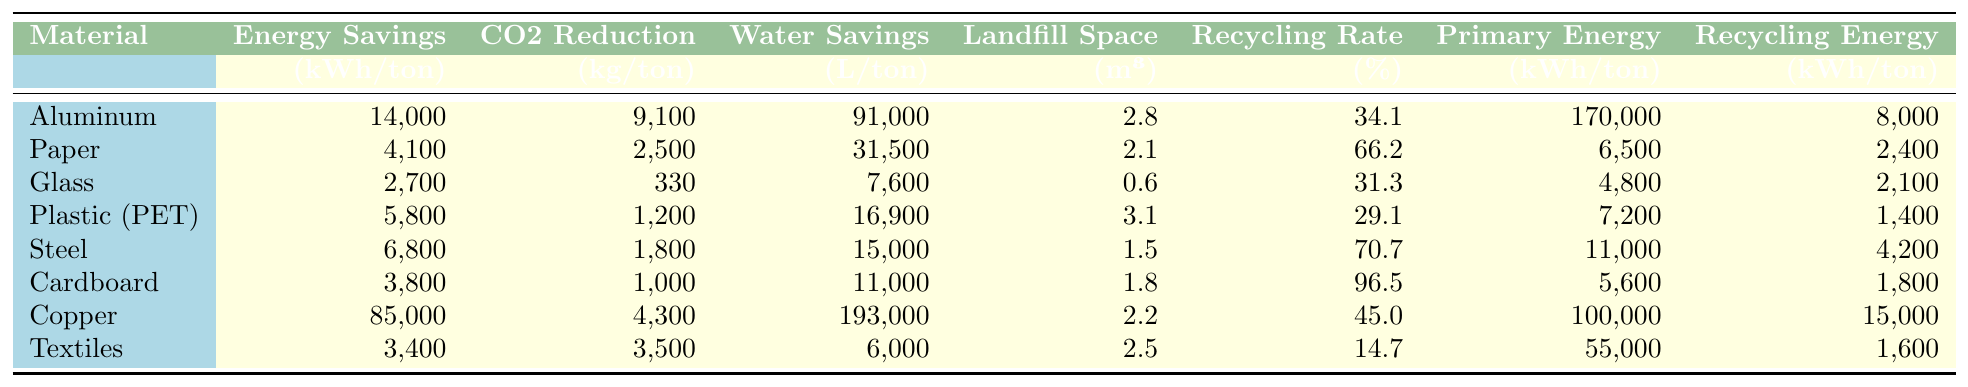What material has the highest CO2 emissions reduction per ton? By examining the "CO2 Reduction" column, we can see that Copper has the highest value of 4,300 kg per ton compared to other materials listed.
Answer: Copper What is the energy savings per ton for Cardboard? Looking under the "Energy Savings" column for Cardboard, the value is 3,800 kWh per ton.
Answer: 3,800 kWh Which material has the lowest recycling rate? Among the recycling rates listed, Textiles has the lowest rate at 14.7%.
Answer: Textiles What is the difference in CO2 emissions reduction between Aluminum and Plastic (PET)? The CO2 emissions reduction for Aluminum is 9,100 kg and for Plastic (PET) it is 1,200 kg. Therefore, the difference is 9,100 - 1,200 = 7,900 kg.
Answer: 7,900 kg What is the average energy savings for all materials listed? The total energy savings is the sum of all values in the "Energy Savings" column, which equals 14,000 + 4,100 + 2,700 + 5,800 + 6,800 + 3,800 + 85,000 + 3,400 = 125,700 kWh. Dividing this by 8 (the number of materials), the average is 125,700 / 8 = 15,712.5 kWh per ton.
Answer: 15,712.5 kWh Is the water savings per ton higher for Steel than for Glass? The water savings for Steel is 15,000 liters, while for Glass it is 7,600 liters. Since 15,000 is greater than 7,600, the statement is true.
Answer: Yes What material saves the most water per ton? By checking the "Water Savings" column, we find that Copper has the highest value of 193,000 liters per ton, which is greater than all other materials.
Answer: Copper Which material has the second highest energy savings after Copper? The next highest energy savings after Copper (85,000 kWh) is Aluminum at 14,000 kWh.
Answer: Aluminum If we combine the CO2 reduction of Cardboard and Glass, what is the total reduction? Cardboard has a CO2 reduction of 1,000 kg, and Glass has 330 kg. Adding these two values together, we get 1,000 + 330 = 1,330 kg.
Answer: 1,330 kg What percentage of the recycling rate is higher for Plastic (PET) compared to Paper? Plastic (PET) has a recycling rate of 29.1%, while Paper has 66.2%. Comparing these values, Paper has a significantly higher rate, not Plastic (PET).
Answer: No What is the relationship between Primary Production Energy and Recycling Process Energy for Steel? For Steel, the Primary Production Energy is 11,000 kWh and the Recycling Process Energy is 4,200 kWh. The Primary Production Energy is significantly higher, indicating that producing new Steel consumes more energy than recycling it.
Answer: Higher Primary Production Energy 